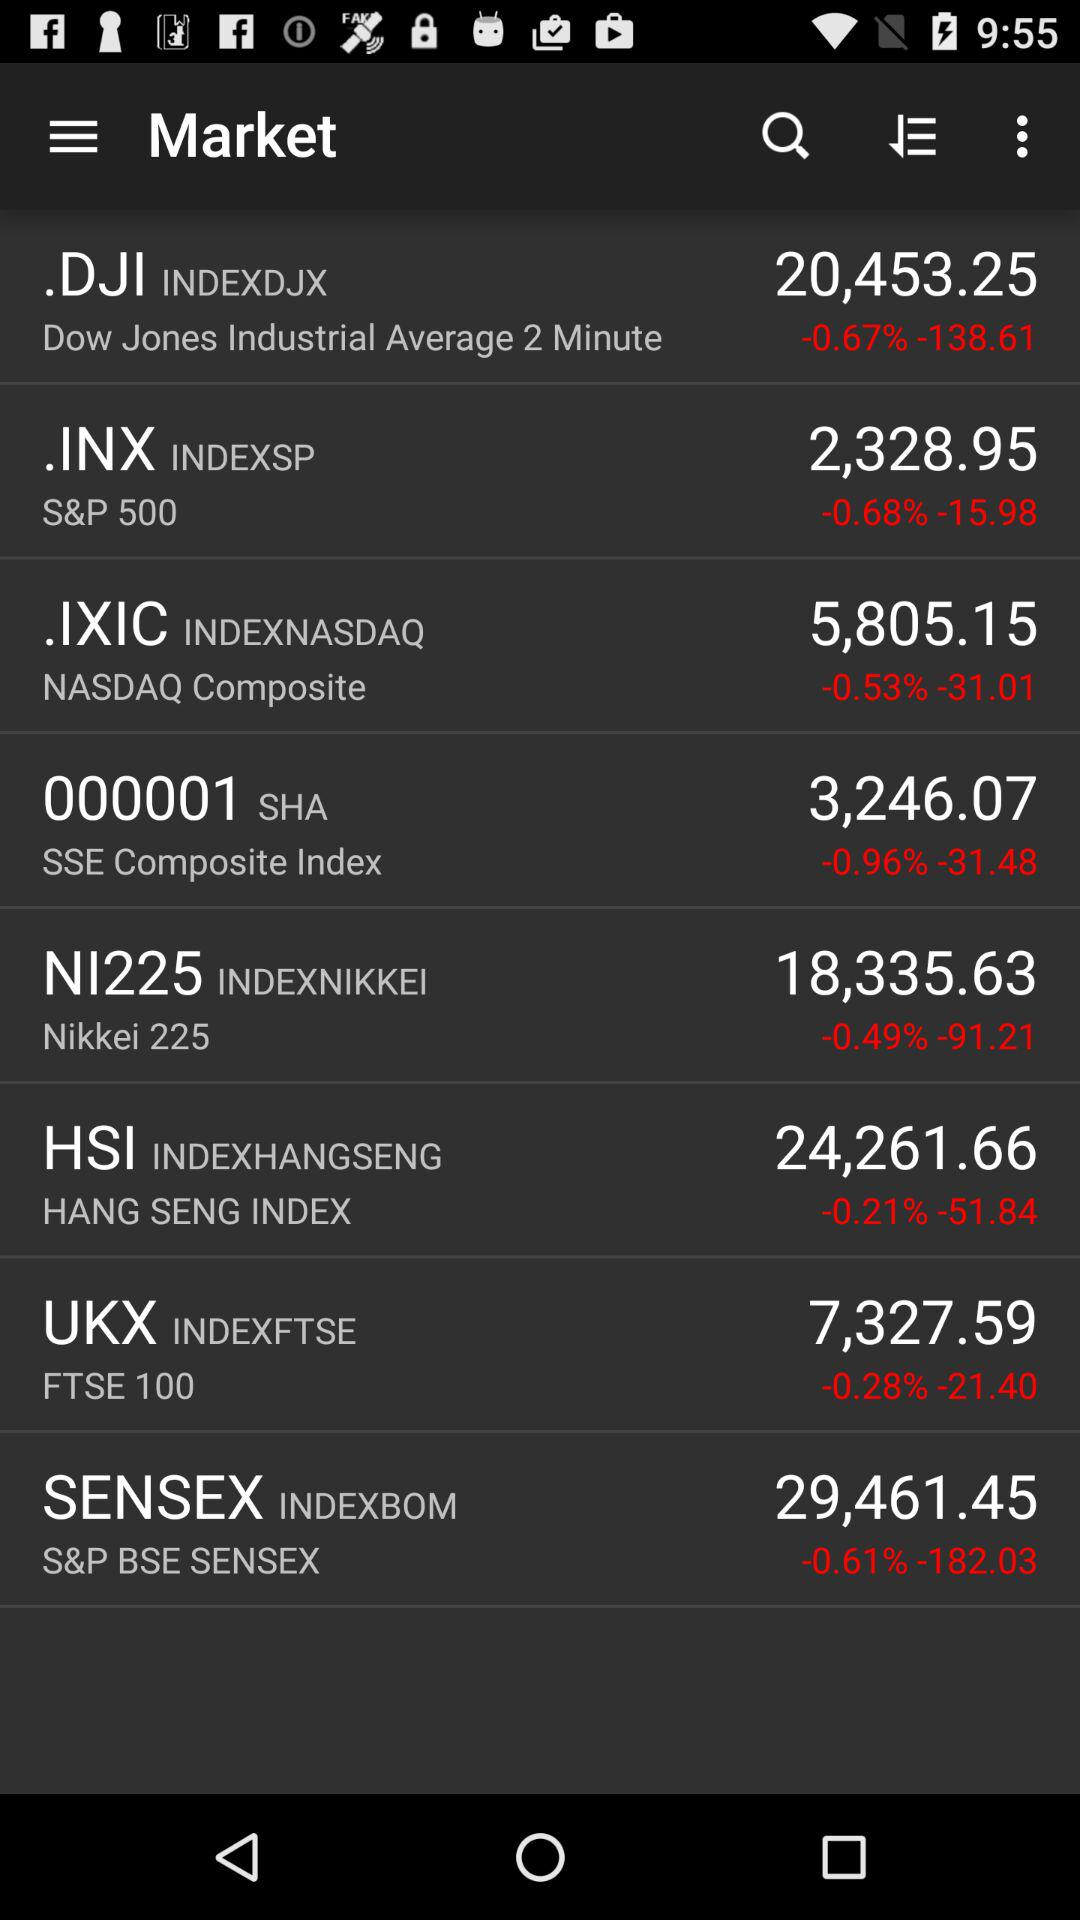What is the price of.DJI? The price is 20,453.25. 